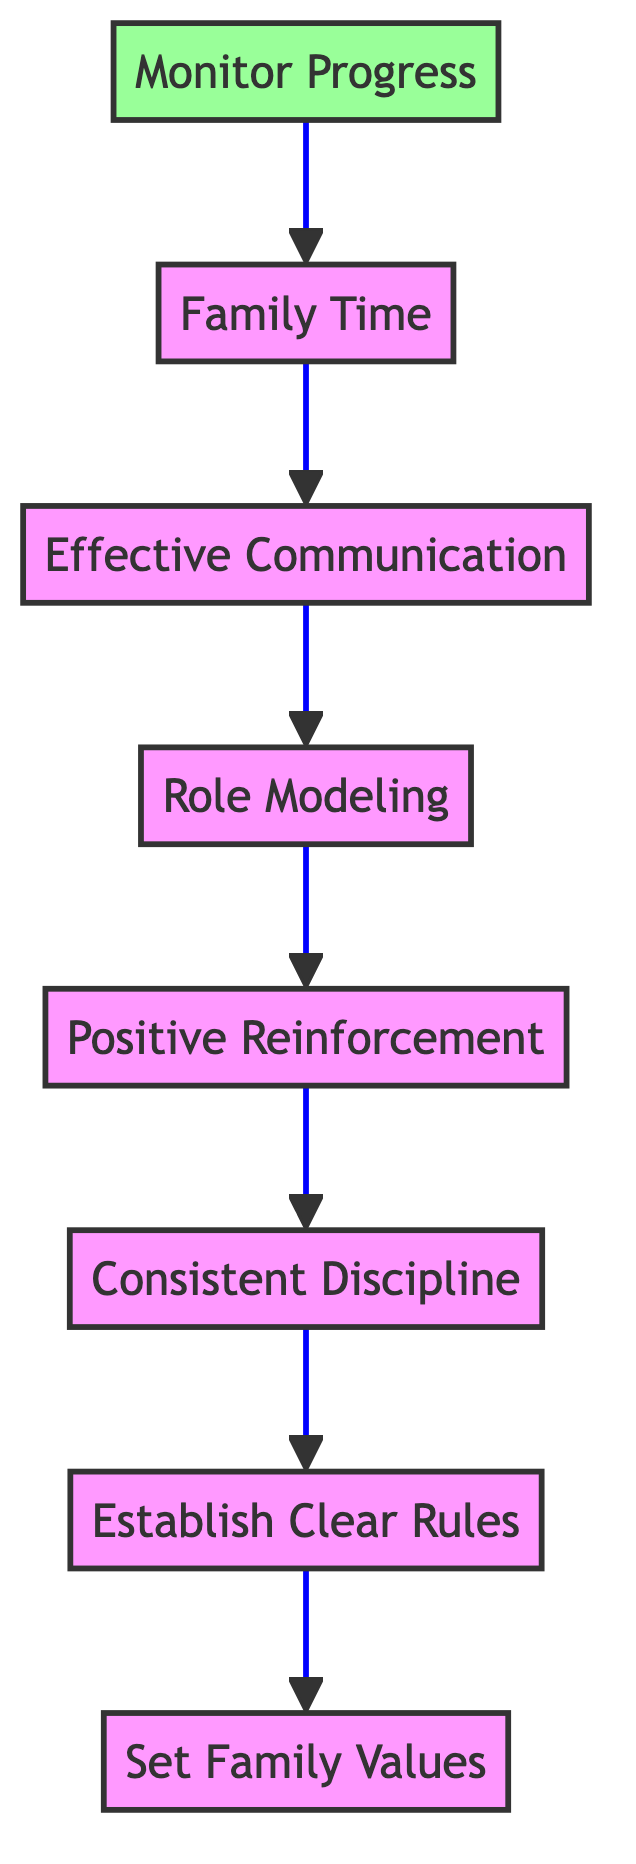What is the top node in the diagram? The top node in the diagram represents the overall aim, which is "Monitor Progress". This is the final step in the flow, indicating that after all other actions, progress should be assessed.
Answer: Monitor Progress How many main nodes are there in the diagram? By counting the distinct sections in the flow chart, there are eight main nodes present, which cover various aspects of family values and parenting guidelines.
Answer: Eight What is the relation between "Positive Reinforcement" and "Consistent Discipline"? The diagram shows that "Consistent Discipline" flows directly into "Positive Reinforcement", which implies that discipline methods lead to the reinforcement of positive behavior.
Answer: Consistent Discipline flows into Positive Reinforcement What node comes after "Family Time"? Following the "Family Time" node, the flow progresses to "Effective Communication". This indicates that after family bonding, the emphasis is placed on ensuring open communication.
Answer: Effective Communication How many nodes feed into "Establish Clear Rules"? There is one node that directly feeds into "Establish Clear Rules", which is "Consistent Discipline". This shows that clear rules are established through the application of fair discipline strategies.
Answer: One What is the purpose of "Role Modeling" in the flow? "Role Modeling" serves as a foundation for encouraging the behaviors parents wish to instill, reinforcing the importance of demonstrating these values consistently.
Answer: Demonstrating behaviors Which node is at the base of the flowchart? The base of the flowchart is the node "Set Family Values", indicating that establishing family values is the starting point for effective parenting strategies.
Answer: Set Family Values What is the order of the nodes from bottom to top? The order is as follows: Set Family Values, Establish Clear Rules, Consistent Discipline, Positive Reinforcement, Role Modeling, Effective Communication, Family Time, and Monitor Progress.
Answer: Set Family Values, Establish Clear Rules, Consistent Discipline, Positive Reinforcement, Role Modeling, Effective Communication, Family Time, Monitor Progress How does "Monitor Progress" relate to the other nodes? "Monitor Progress" is the ultimate node that encompasses all previous tasks, emphasizing the need for ongoing assessment of parenting practices and adherence to family values.
Answer: Assessment of practices 